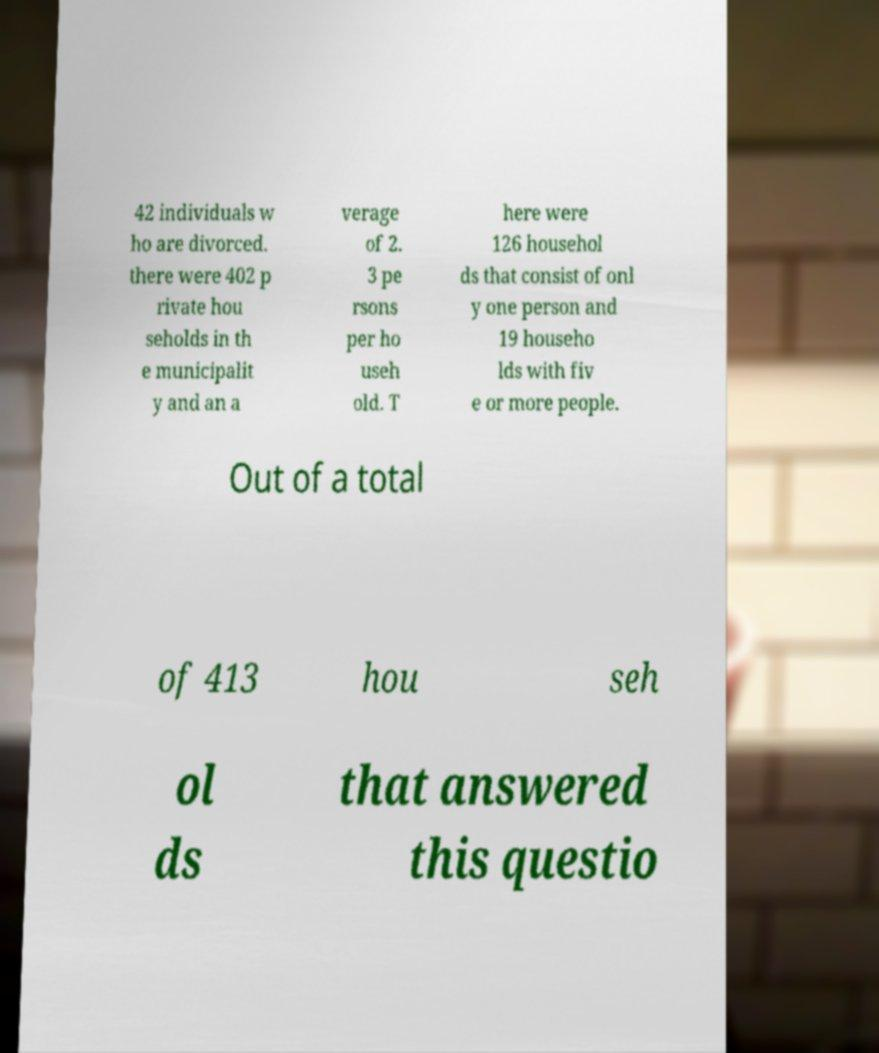Can you read and provide the text displayed in the image?This photo seems to have some interesting text. Can you extract and type it out for me? 42 individuals w ho are divorced. there were 402 p rivate hou seholds in th e municipalit y and an a verage of 2. 3 pe rsons per ho useh old. T here were 126 househol ds that consist of onl y one person and 19 househo lds with fiv e or more people. Out of a total of 413 hou seh ol ds that answered this questio 